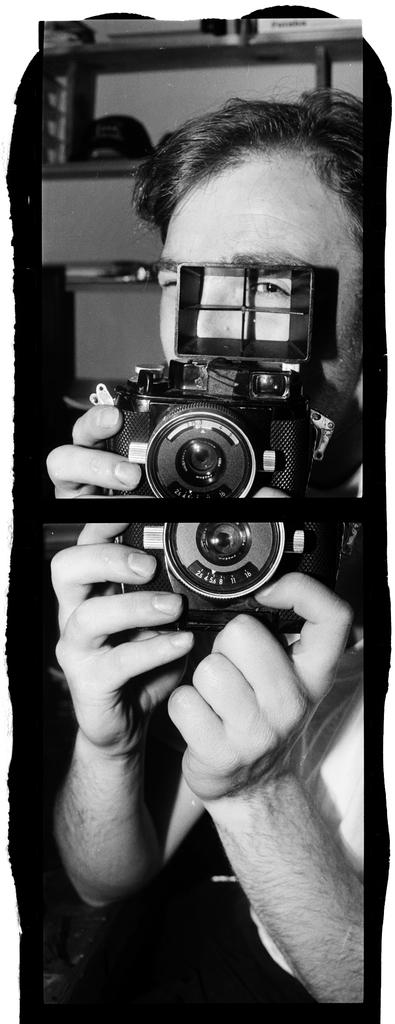What can be observed about the composition of the image? The image is a combination of two images. Can you describe the person in the image? There is a person in the image. What is the person holding in the image? The person is holding a camera. What type of worm can be seen crawling on the person's arm in the image? There is no worm present in the image; it only shows a person holding a camera. 